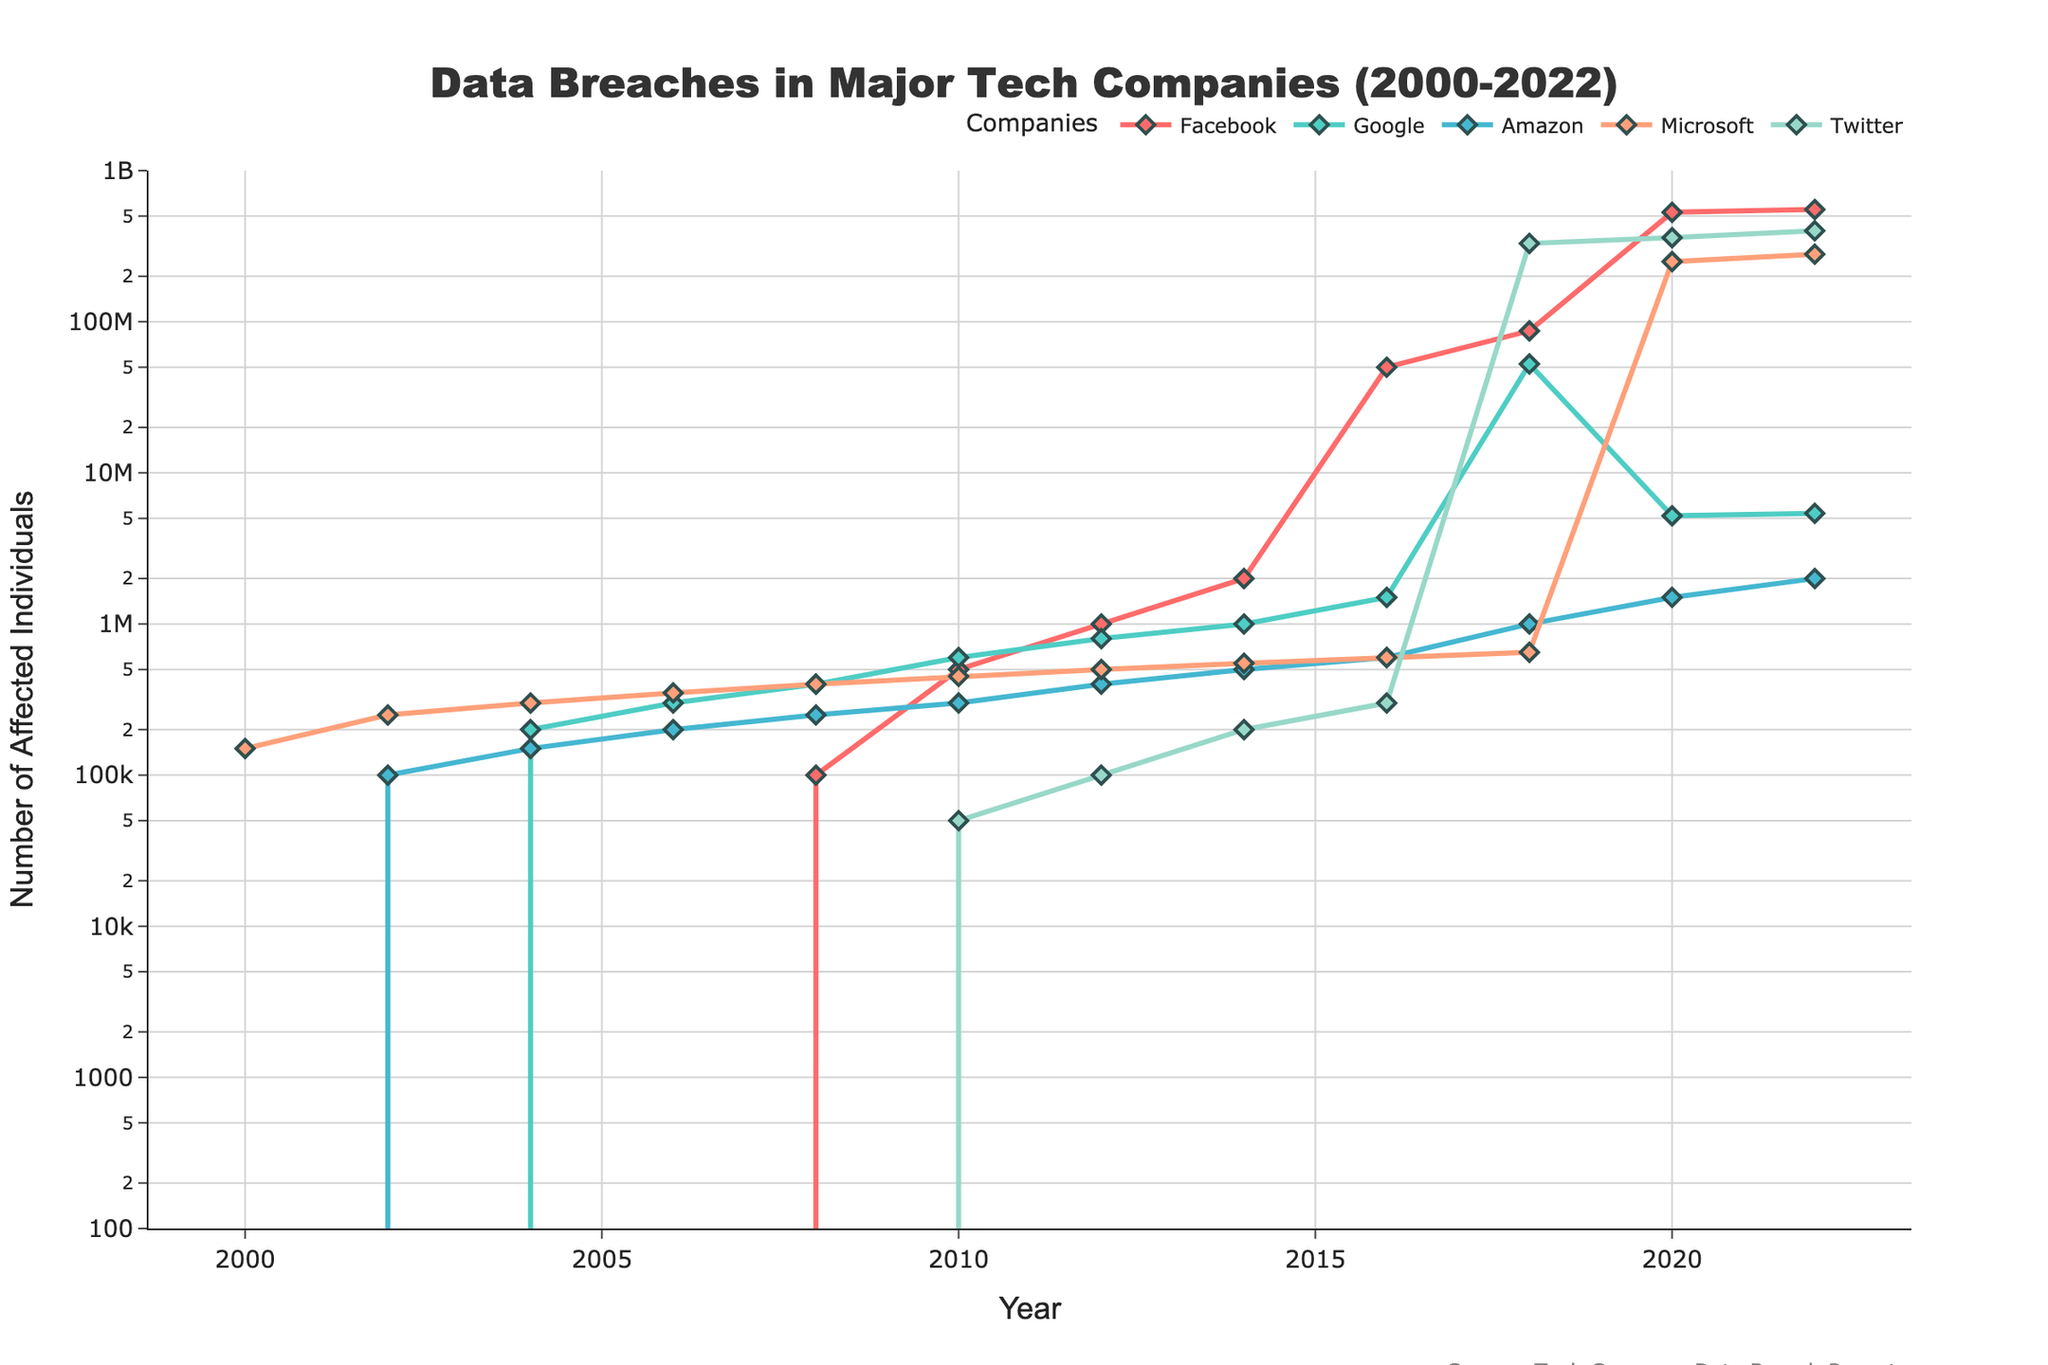What's the total number of affected individuals for Facebook from 2008 to 2012? Sum the data points for Facebook for the years 2008 (100,000), 2010 (500,000), and 2012 (1,000,000). Therefore, the total is 100,000 + 500,000 + 1,000,000 = 1,600,000.
Answer: 1,600,000 Which company experienced the largest single-year jump in the number of affected individuals? Compare the differences year-over-year for each company. Facebook showed the largest increase from 2016 (50,000,000) to 2018 (87,000,000), which is an increase of 37,000,000.
Answer: Facebook In 2018, which company had the highest number of affected individuals, and how many were they? Look at the year 2018 and compare the data for each company. Twitter had the highest with 330,000,000 affected individuals in 2018.
Answer: Twitter, 330,000,000 How much higher was the number of affected individuals in Google compared to Amazon in 2020? Subtract the number of affected individuals for Amazon in 2020 (1,500,000) from Google in 2020 (5,200,000). The difference is 5,200,000 - 1,500,000 = 3,700,000.
Answer: 3,700,000 Which company had the least number of affected individuals in 2022, and what was the number? Look at the year 2022 and compare the data values. Amazon had the least with 2,000,000 affected individuals in 2022.
Answer: Amazon, 2,000,000 From 2014 to 2016, by how much did the number of affected individuals increase for Microsoft? Subtract the 2014 value for Microsoft (550,000) from the 2016 value for Microsoft (600,000). The increase is 600,000 - 550,000 = 50,000.
Answer: 50,000 What is the compound annual growth rate (CAGR) of affected individuals for Facebook from 2008 to 2022? To get CAGR: 
\[
\text{CAGR} = \left( \frac{553,000,000}{100,000} \right)^{\frac{1}{14}} - 1
\]
where 553,000,000 is the end value, 100,000 is the start value, and 14 is the number of periods.
Answer: 0.804 or 80.4% Which two companies had the closest number of affected individuals in the year 2004? Compare the data points for the year 2004. Amazon (150,000) and Google (200,000) had the closest values with a difference of 50,000.
Answer: Amazon and Google By what factor did Twitter’s number of affected individuals increase from 2014 to 2022? Divide the 2022 value (400,000,000) by the 2014 value (200,000). The factor is \( \frac{400,000,000}{200,000} = 2000 \).
Answer: 2000 